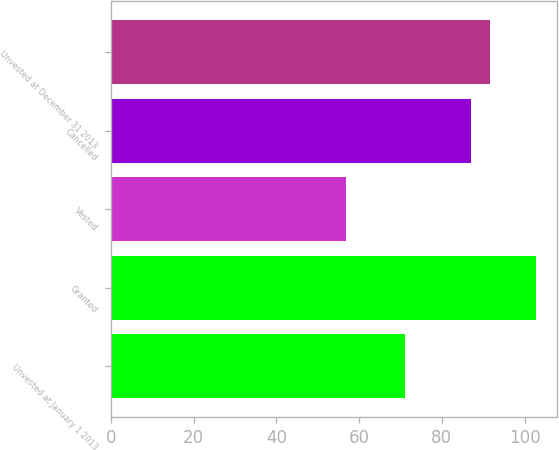Convert chart. <chart><loc_0><loc_0><loc_500><loc_500><bar_chart><fcel>Unvested at January 1 2013<fcel>Granted<fcel>Vested<fcel>Cancelled<fcel>Unvested at December 31 2013<nl><fcel>71.01<fcel>102.75<fcel>56.74<fcel>87.05<fcel>91.65<nl></chart> 